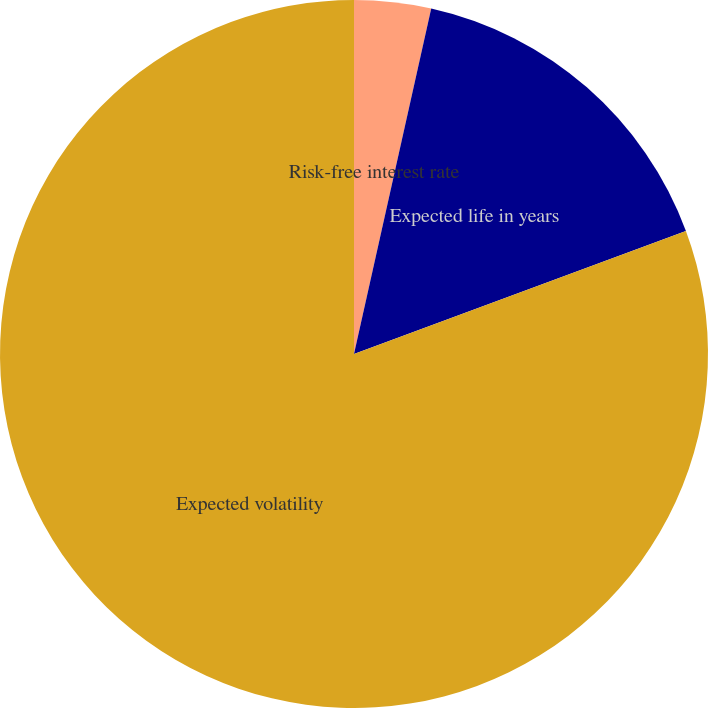Convert chart to OTSL. <chart><loc_0><loc_0><loc_500><loc_500><pie_chart><fcel>Risk-free interest rate<fcel>Expected life in years<fcel>Expected volatility<nl><fcel>3.5%<fcel>15.85%<fcel>80.65%<nl></chart> 